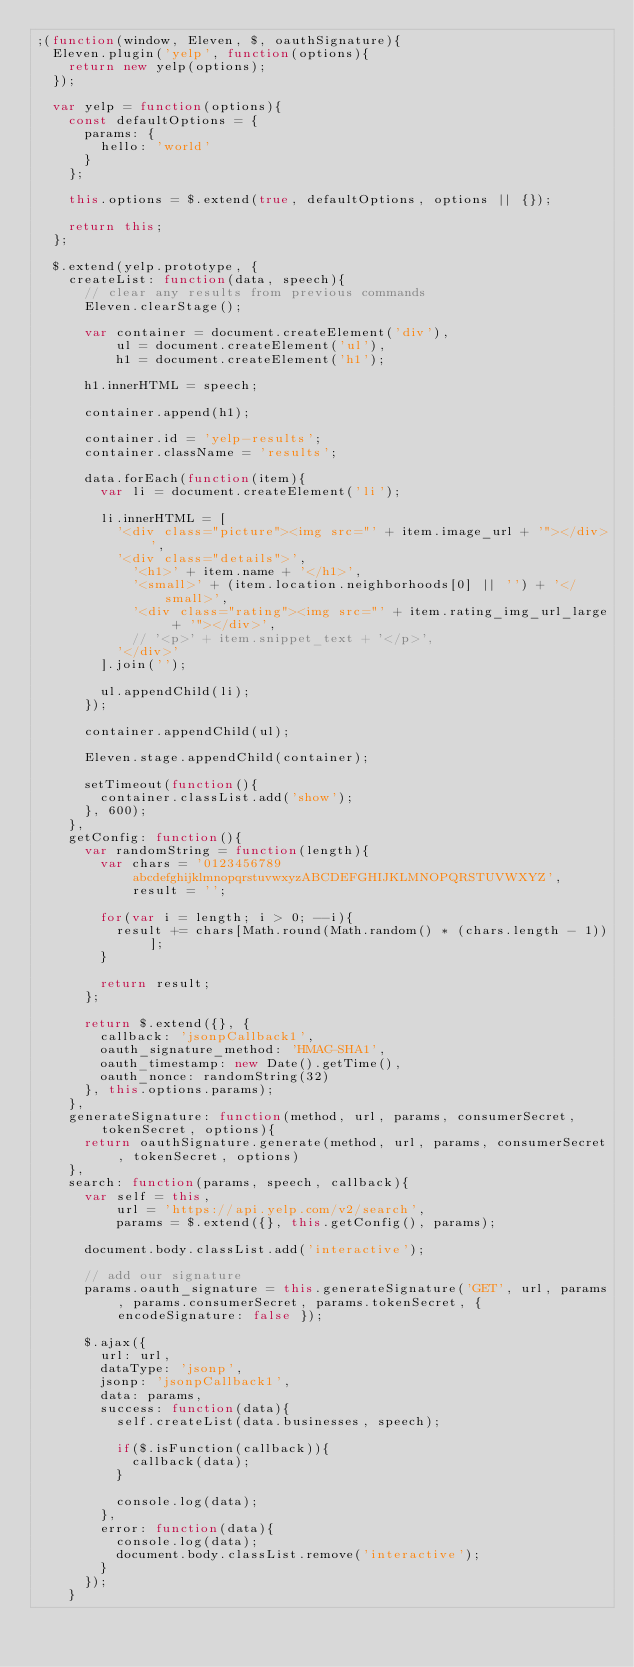<code> <loc_0><loc_0><loc_500><loc_500><_JavaScript_>;(function(window, Eleven, $, oauthSignature){
  Eleven.plugin('yelp', function(options){
    return new yelp(options);
  });

  var yelp = function(options){
    const defaultOptions = {
      params: {
        hello: 'world'
      }
    };

    this.options = $.extend(true, defaultOptions, options || {});

    return this;
  };

  $.extend(yelp.prototype, {
    createList: function(data, speech){
      // clear any results from previous commands
      Eleven.clearStage();

      var container = document.createElement('div'),
          ul = document.createElement('ul'),
          h1 = document.createElement('h1');

      h1.innerHTML = speech;

      container.append(h1);

      container.id = 'yelp-results';
      container.className = 'results';

      data.forEach(function(item){
        var li = document.createElement('li');

        li.innerHTML = [
          '<div class="picture"><img src="' + item.image_url + '"></div>',
          '<div class="details">',
            '<h1>' + item.name + '</h1>',
            '<small>' + (item.location.neighborhoods[0] || '') + '</small>',
            '<div class="rating"><img src="' + item.rating_img_url_large + '"></div>',
            // '<p>' + item.snippet_text + '</p>',
          '</div>'
        ].join('');

        ul.appendChild(li);
      });

      container.appendChild(ul);

      Eleven.stage.appendChild(container);

      setTimeout(function(){
        container.classList.add('show');
      }, 600);
    },
    getConfig: function(){
      var randomString = function(length){
        var chars = '0123456789abcdefghijklmnopqrstuvwxyzABCDEFGHIJKLMNOPQRSTUVWXYZ',
            result = '';

        for(var i = length; i > 0; --i){
          result += chars[Math.round(Math.random() * (chars.length - 1))];
        }

        return result;
      };

      return $.extend({}, {
        callback: 'jsonpCallback1',
        oauth_signature_method: 'HMAC-SHA1',
        oauth_timestamp: new Date().getTime(),
        oauth_nonce: randomString(32)
      }, this.options.params);
    },
    generateSignature: function(method, url, params, consumerSecret, tokenSecret, options){
      return oauthSignature.generate(method, url, params, consumerSecret, tokenSecret, options)
    },
    search: function(params, speech, callback){
      var self = this,
          url = 'https://api.yelp.com/v2/search',
          params = $.extend({}, this.getConfig(), params);

      document.body.classList.add('interactive');

      // add our signature
      params.oauth_signature = this.generateSignature('GET', url, params, params.consumerSecret, params.tokenSecret, { encodeSignature: false });

      $.ajax({
        url: url,
        dataType: 'jsonp',
        jsonp: 'jsonpCallback1',
        data: params,
        success: function(data){
          self.createList(data.businesses, speech);

          if($.isFunction(callback)){
            callback(data);
          }

          console.log(data);
        },
        error: function(data){
          console.log(data);
          document.body.classList.remove('interactive');
        }
      });
    }</code> 